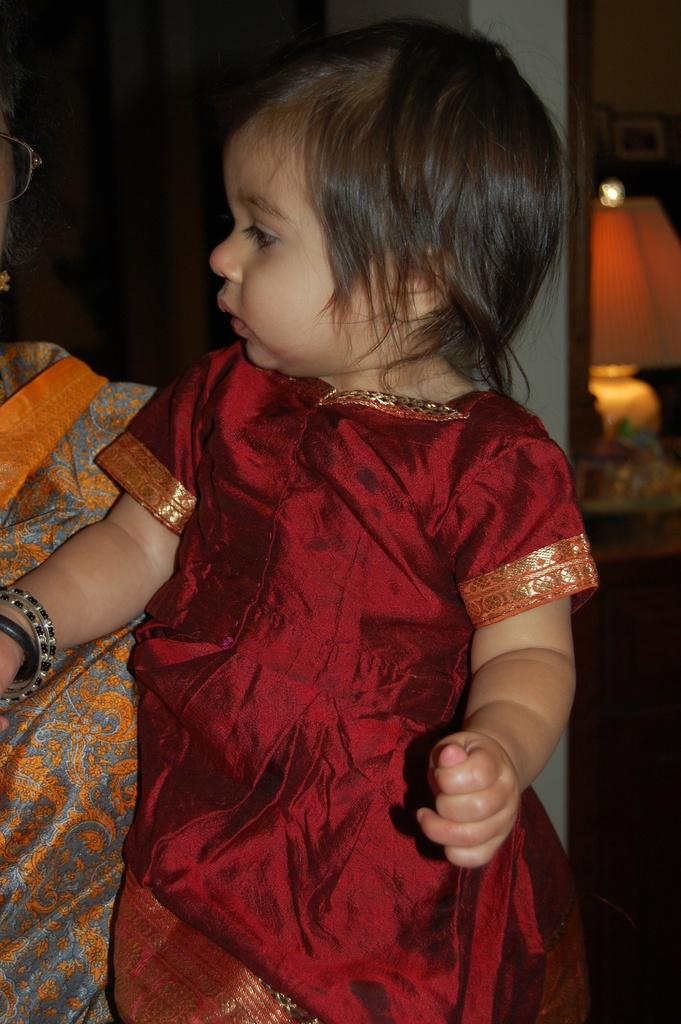What is the lady in the image doing? The lady is holding a baby in the image. What is the baby wearing? The baby is wearing a red dress. What can be seen behind the baby? There is a wall behind the baby. Can you describe any other objects in the image? Yes, there is a lamp present in the image. What substance is the baby playing with in the image? There is no substance present in the image, and the baby is not shown playing with anything. 